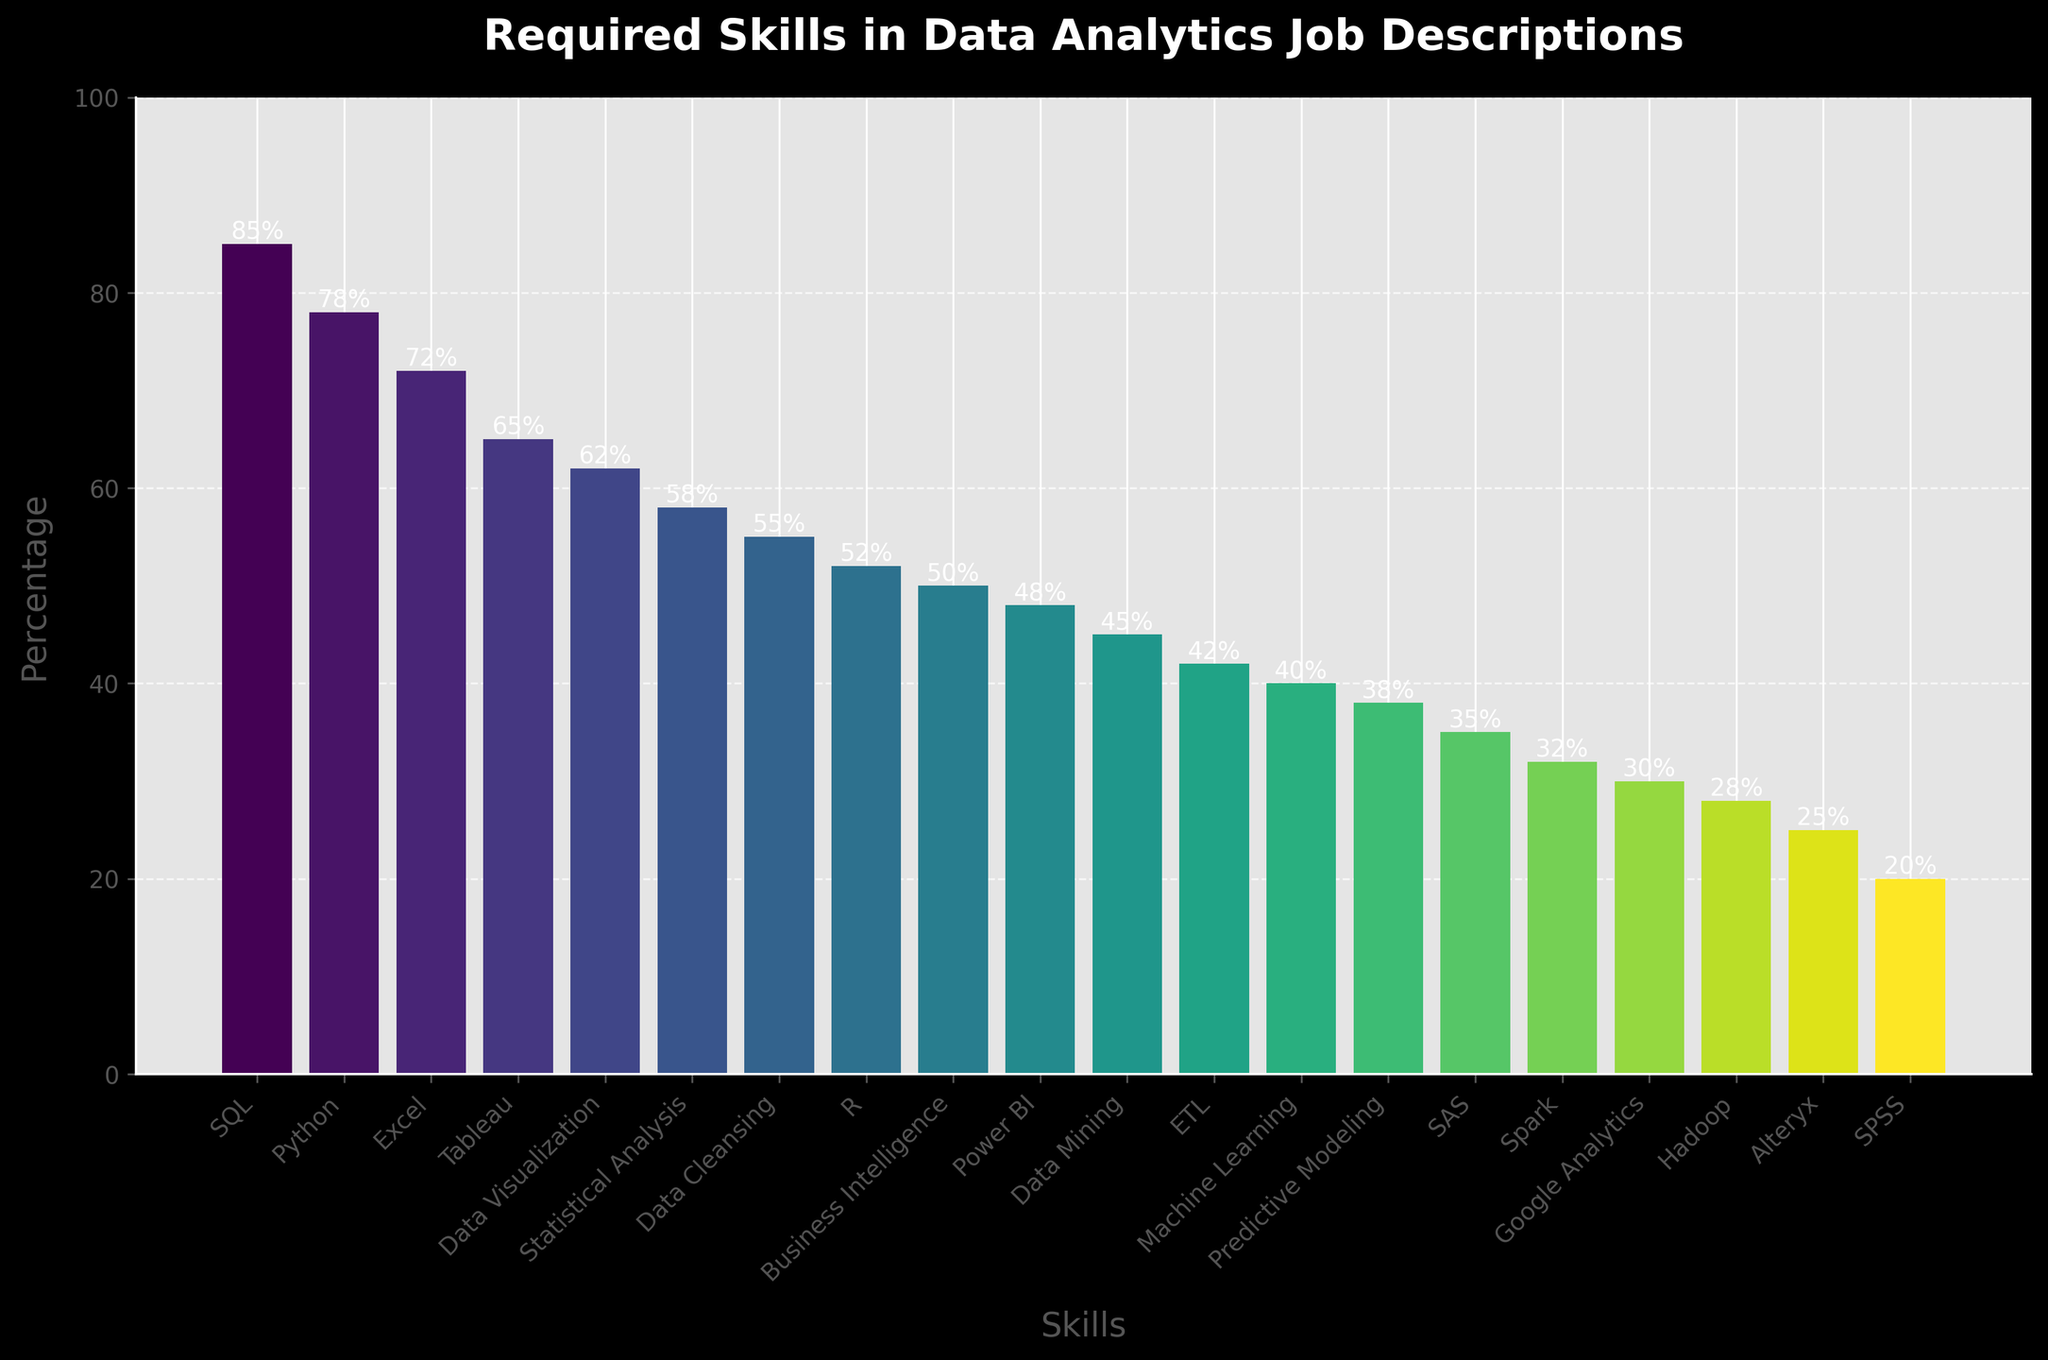Which skill is mentioned in the highest percentage of job descriptions? The highest bar in the bar chart corresponds to SQL, which is at the far left. This bar reaches 85%, making it the most mentioned skill.
Answer: SQL Which skill is mentioned less frequently, Hadoop or Spark? By comparing the heights of the bars for Hadoop and Spark, we observe that Hadoop (28%) is mentioned less frequently than Spark (32%).
Answer: Hadoop What is the combined percentage for all the statistical and data visualization tools (R, SAS, Data Visualization, Statistical Analysis, SPSS)? To get the combined percentage, we add up the percentages for R (52%), SAS (35%), Data Visualization (62%), Statistical Analysis (58%), and SPSS (20%): 52 + 35 + 62 + 58 + 20 = 227%.
Answer: 227% How much more frequently is SQL mentioned compared to Power BI? SQL is mentioned 85% of the time, whereas Power BI is mentioned 48% of the time. Subtracting these values gives the difference: 85% - 48% = 37%.
Answer: 37% Which skills are mentioned in at least 50% but less than 70% of job descriptions? From the bar chart, we see that Excel (72%) is above 70%, but Data Visualization (62%), Statistical Analysis (58%), Data Cleansing (55%), and Business Intelligence (50%) fall between 50% and 70%.
Answer: Data Visualization, Statistical Analysis, Data Cleansing, Business Intelligence By how much does the percentage of job descriptions mentioning Excel exceed that of job descriptions mentioning Alteryx? Excel is mentioned in 72% of job descriptions, and Alteryx is mentioned in 25%. The difference is found by subtracting the smaller value from the larger value: 72% - 25% = 47%.
Answer: 47% Which skills are mentioned at least twice as much as Hadoop? Twice the percentage of Hadoop (28%) is 56%. The skills mentioned at least 56% are SQL (85%), Python (78%), Excel (72%), Data Visualization (62%), and Statistical Analysis (58%).
Answer: SQL, Python, Excel, Data Visualization, Statistical Analysis 